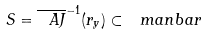Convert formula to latex. <formula><loc_0><loc_0><loc_500><loc_500>S = \overline { \ A J } ^ { - 1 } ( r _ { y } ) \subset \ m a n b a r</formula> 